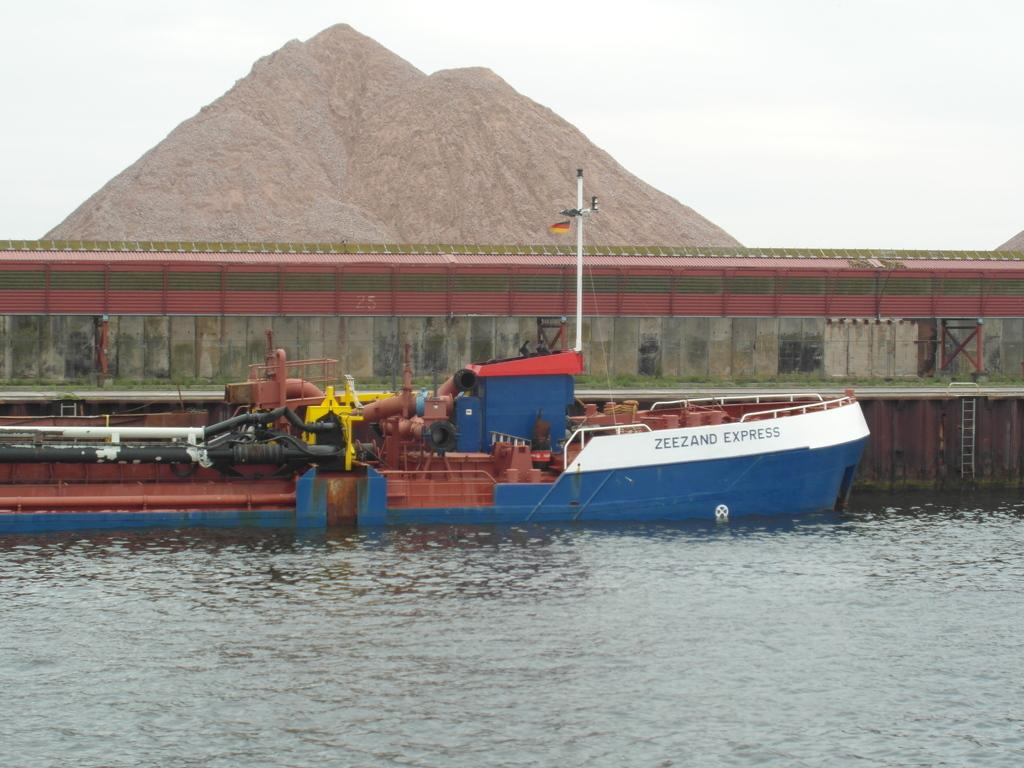What is the main subject in the middle of the image? There is a boat in the middle of the image. What type of environment is depicted in the image? The image shows water at the bottom and the sky at the top, suggesting a water-based environment. What type of bean is visible in the image? There are no beans present in the image; it features a boat in a water-based environment. What part of the human body can be seen in the image? There are no human body parts visible in the image; it features a boat in a water-based environment. 